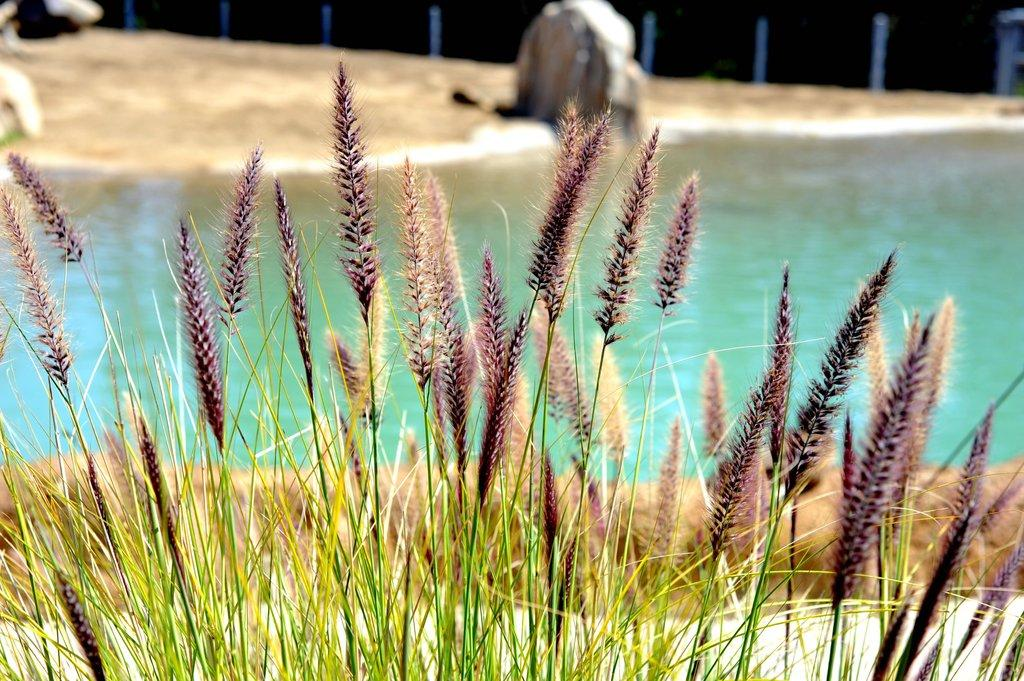What is located in the foreground of the image? There are plants in the foreground of the image. What can be seen in the image besides the plants? There is water visible in the image, as well as a rock in the middle of the image. What type of terrain is visible in the background of the image? There is sand in the background of the image. How many cameras can be seen in the image? There are no cameras present in the image. What type of pin is used to hold the plants in place in the image? There is no pin visible in the image, and the plants are not held in place by any pin. 